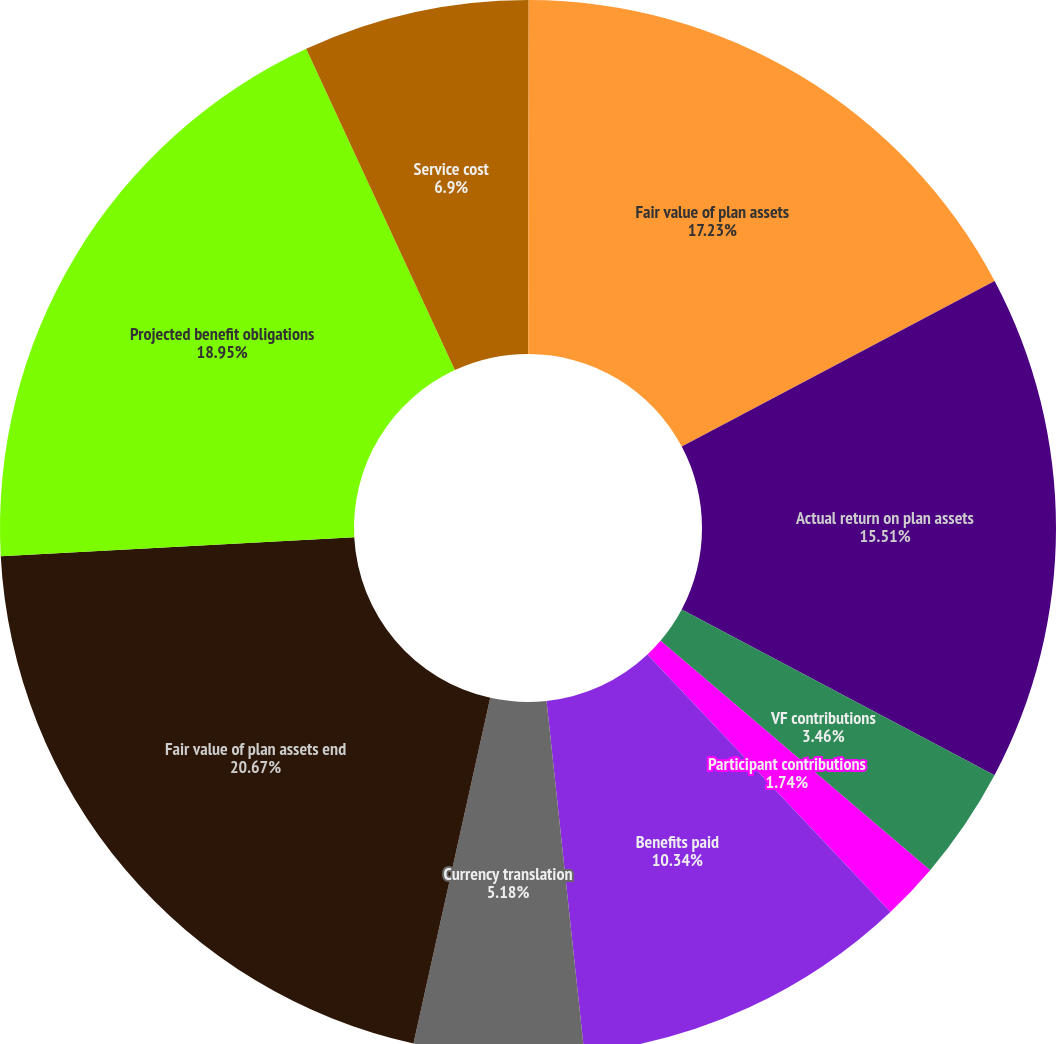Convert chart. <chart><loc_0><loc_0><loc_500><loc_500><pie_chart><fcel>(In thousands)<fcel>Fair value of plan assets<fcel>Actual return on plan assets<fcel>VF contributions<fcel>Participant contributions<fcel>Benefits paid<fcel>Currency translation<fcel>Fair value of plan assets end<fcel>Projected benefit obligations<fcel>Service cost<nl><fcel>0.02%<fcel>17.23%<fcel>15.51%<fcel>3.46%<fcel>1.74%<fcel>10.34%<fcel>5.18%<fcel>20.67%<fcel>18.95%<fcel>6.9%<nl></chart> 